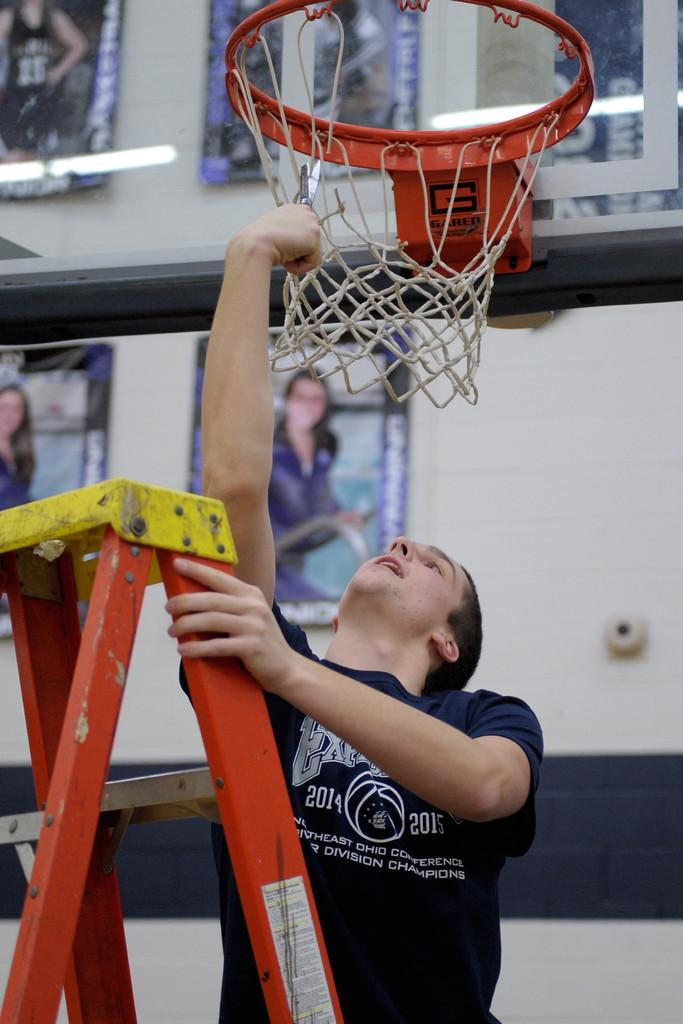<image>
Render a clear and concise summary of the photo. a man that has the year 2014 on his shirt 